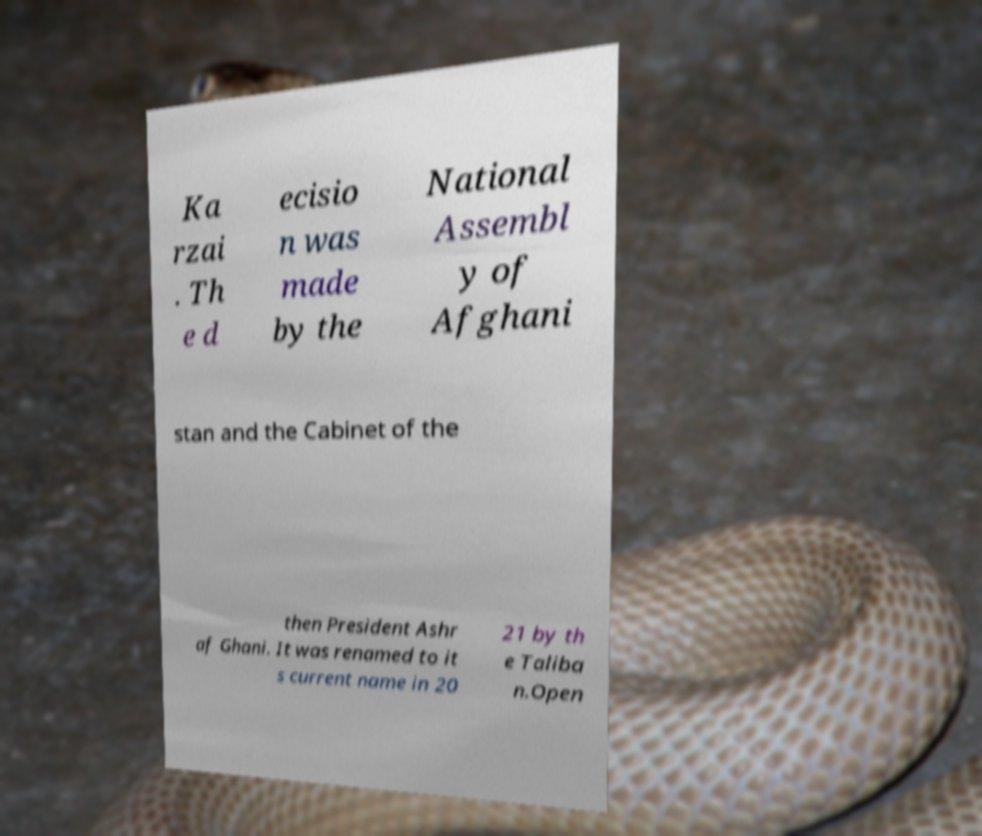Could you assist in decoding the text presented in this image and type it out clearly? Ka rzai . Th e d ecisio n was made by the National Assembl y of Afghani stan and the Cabinet of the then President Ashr af Ghani. It was renamed to it s current name in 20 21 by th e Taliba n.Open 